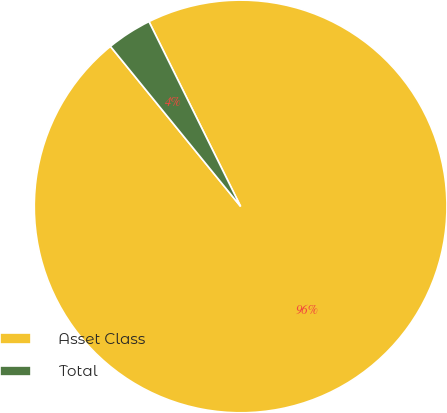Convert chart to OTSL. <chart><loc_0><loc_0><loc_500><loc_500><pie_chart><fcel>Asset Class<fcel>Total<nl><fcel>96.46%<fcel>3.54%<nl></chart> 